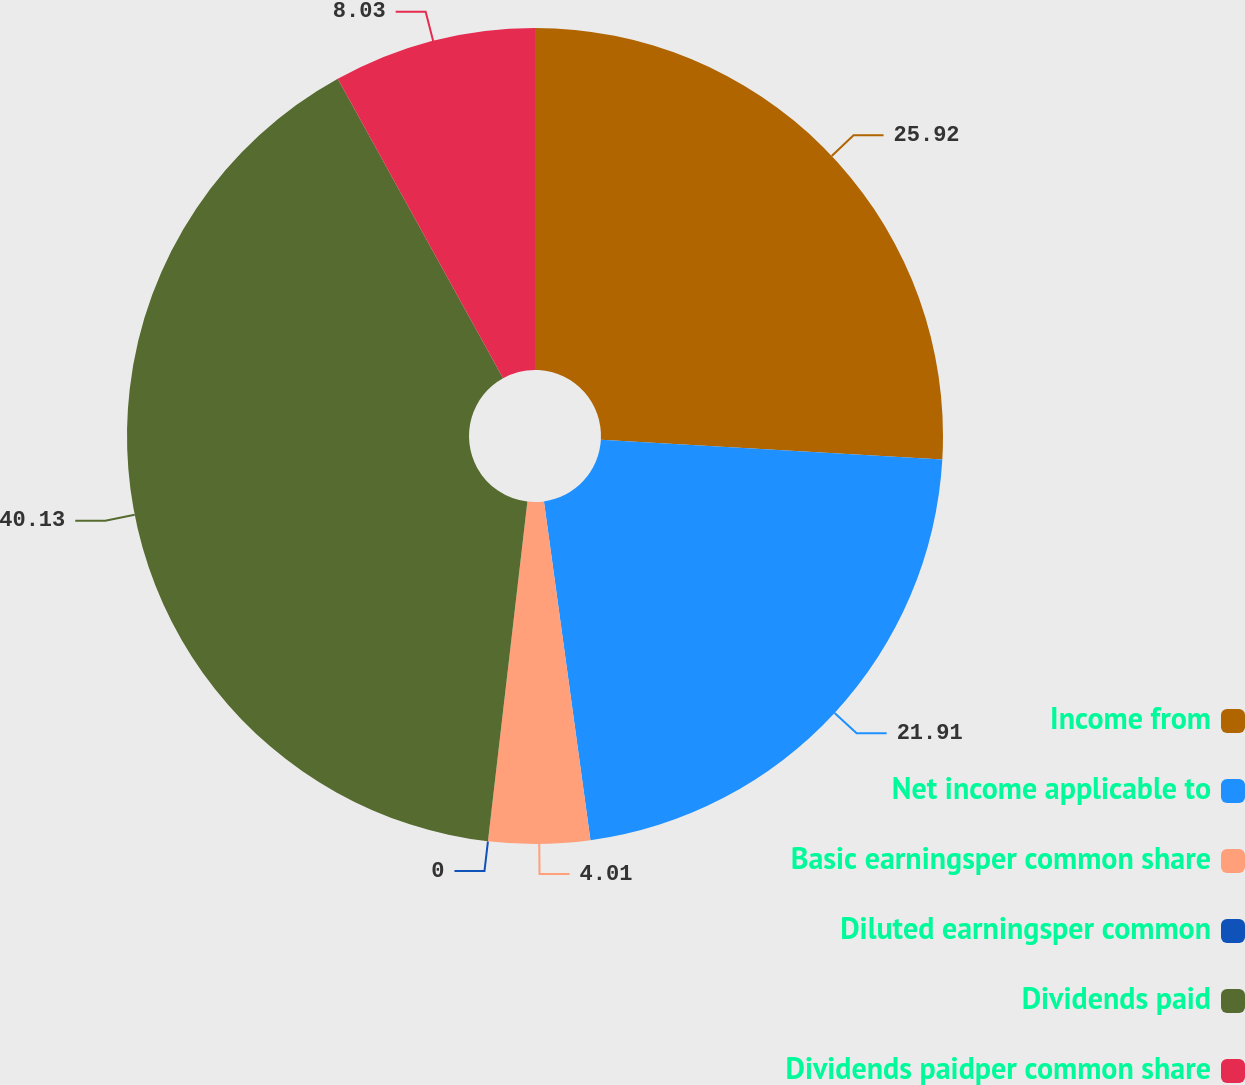<chart> <loc_0><loc_0><loc_500><loc_500><pie_chart><fcel>Income from<fcel>Net income applicable to<fcel>Basic earningsper common share<fcel>Diluted earningsper common<fcel>Dividends paid<fcel>Dividends paidper common share<nl><fcel>25.92%<fcel>21.91%<fcel>4.01%<fcel>0.0%<fcel>40.13%<fcel>8.03%<nl></chart> 